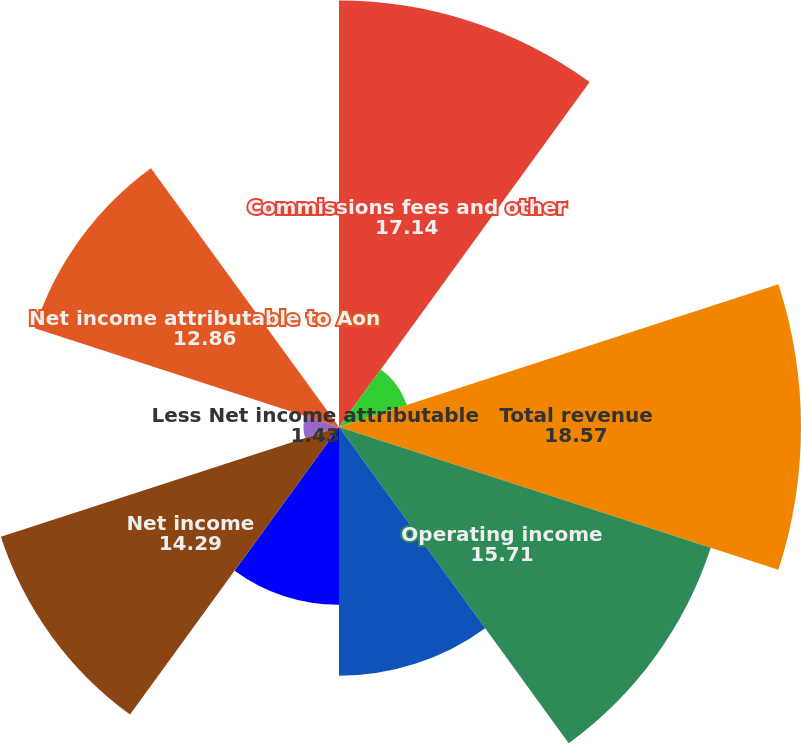<chart> <loc_0><loc_0><loc_500><loc_500><pie_chart><fcel>Commissions fees and other<fcel>Fiduciary investment income<fcel>Total revenue<fcel>Operating income<fcel>Income from continuing<fcel>Income from discontinued<fcel>Net income<fcel>Less Net income attributable<fcel>Net income attributable to Aon<fcel>Dividends paid per share<nl><fcel>17.14%<fcel>2.86%<fcel>18.57%<fcel>15.71%<fcel>10.0%<fcel>7.14%<fcel>14.29%<fcel>1.43%<fcel>12.86%<fcel>0.0%<nl></chart> 